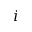Convert formula to latex. <formula><loc_0><loc_0><loc_500><loc_500>i</formula> 